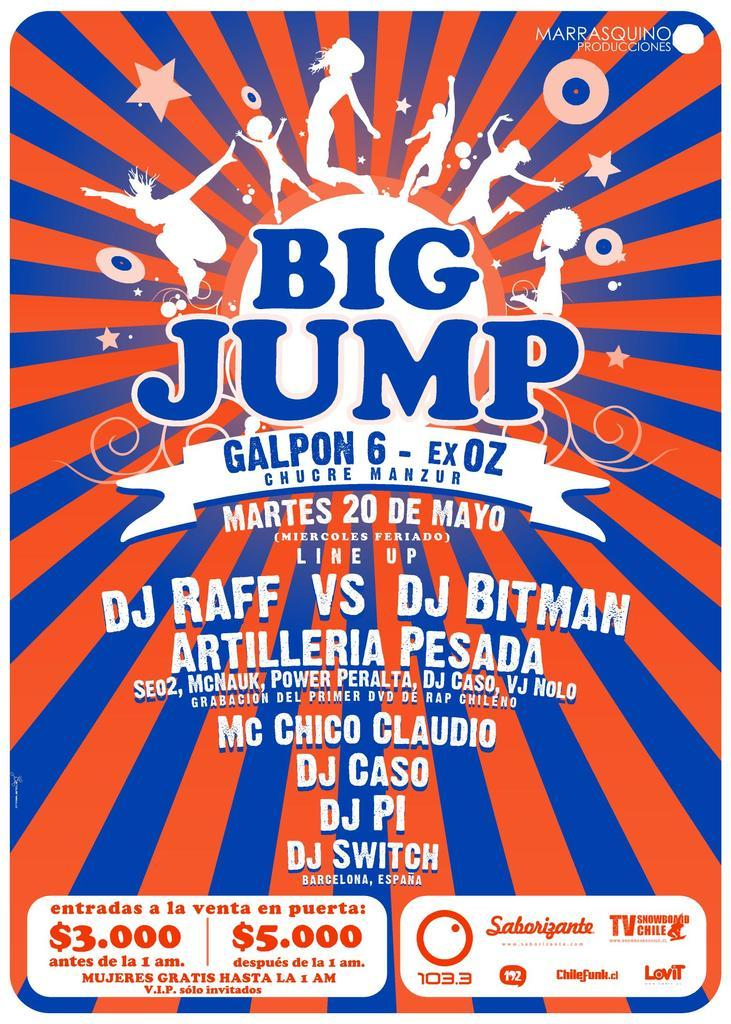<image>
Present a compact description of the photo's key features. A poster for the Big Jump which is designed using the colors red and blue. 